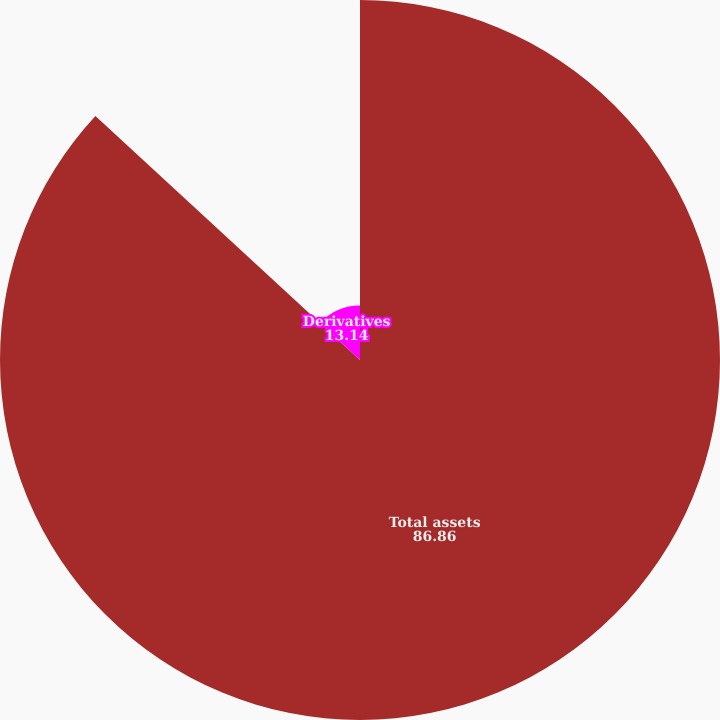<chart> <loc_0><loc_0><loc_500><loc_500><pie_chart><fcel>Total assets<fcel>Derivatives<nl><fcel>86.86%<fcel>13.14%<nl></chart> 